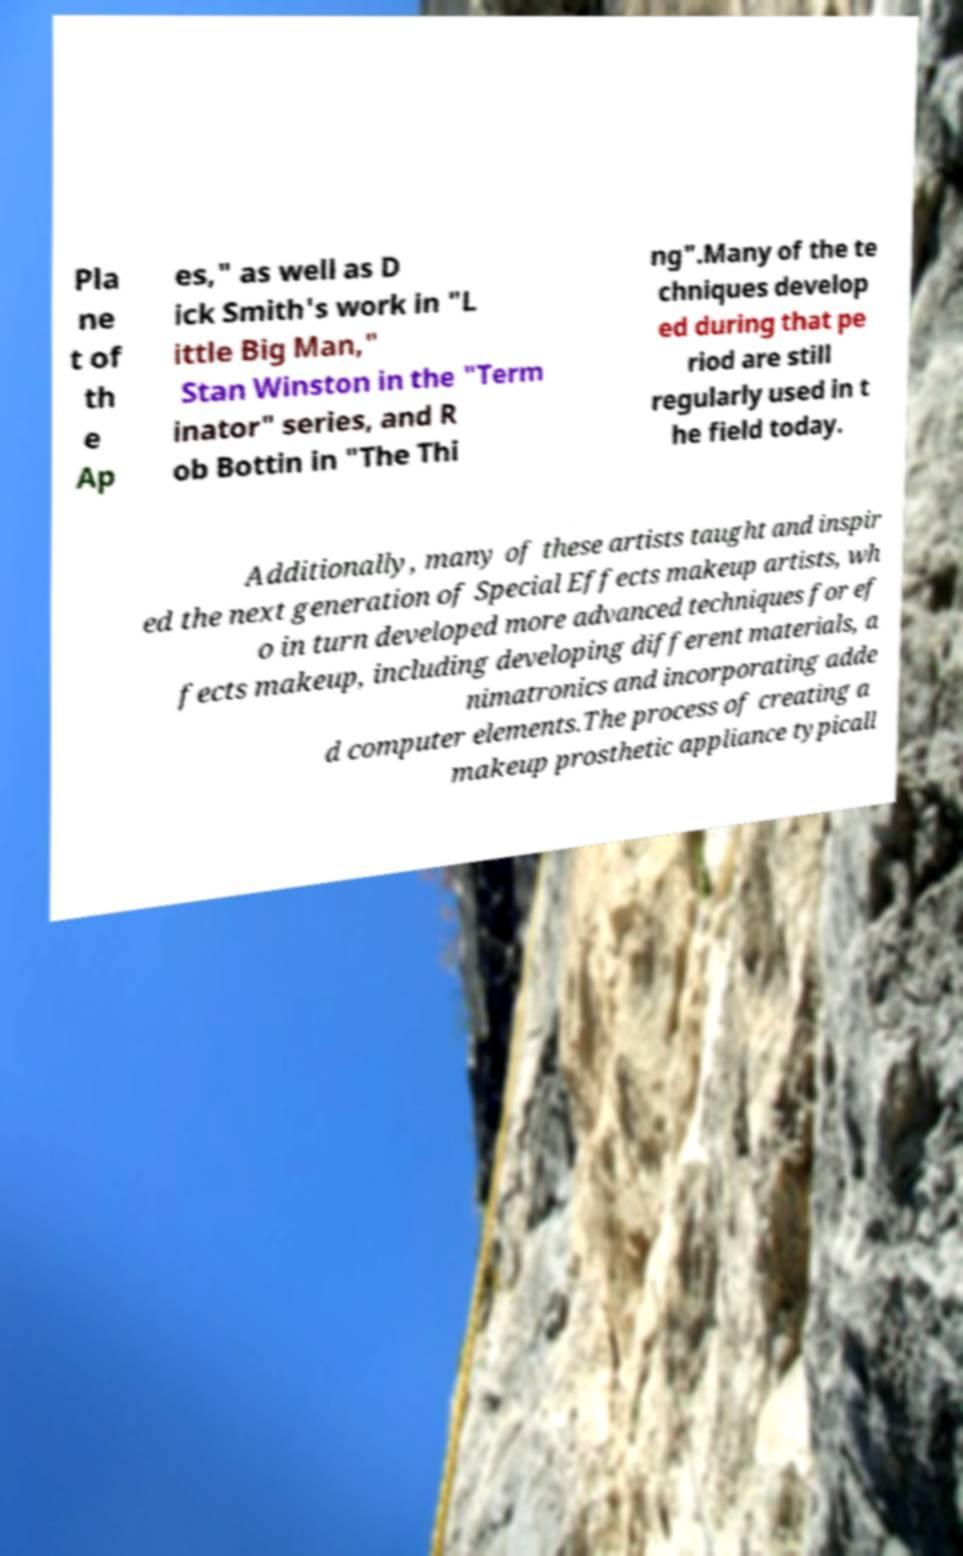Please identify and transcribe the text found in this image. Pla ne t of th e Ap es," as well as D ick Smith's work in "L ittle Big Man," Stan Winston in the "Term inator" series, and R ob Bottin in "The Thi ng".Many of the te chniques develop ed during that pe riod are still regularly used in t he field today. Additionally, many of these artists taught and inspir ed the next generation of Special Effects makeup artists, wh o in turn developed more advanced techniques for ef fects makeup, including developing different materials, a nimatronics and incorporating adde d computer elements.The process of creating a makeup prosthetic appliance typicall 